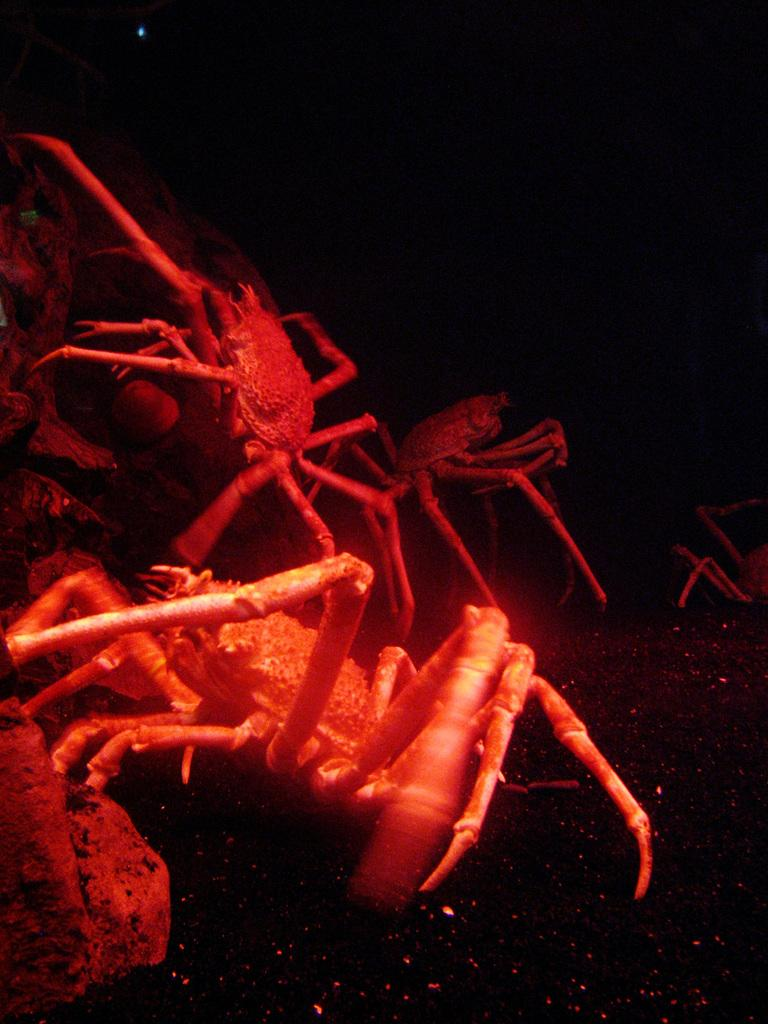What type of animals are present in the image? There are red-colored crabs in the image. Can you describe the lighting or color tone of the image? The image appears to be slightly dark. What color is the tiger's stripe in the image? There is no tiger present in the image, so it is not possible to determine the color of its stripes. 